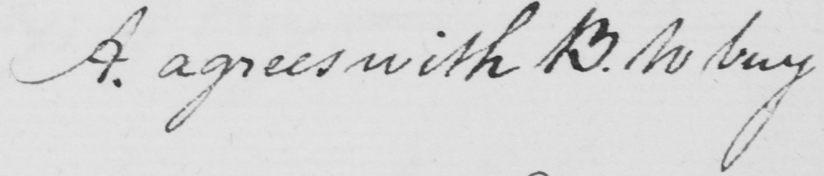What does this handwritten line say? A . agrees with B . to buy 